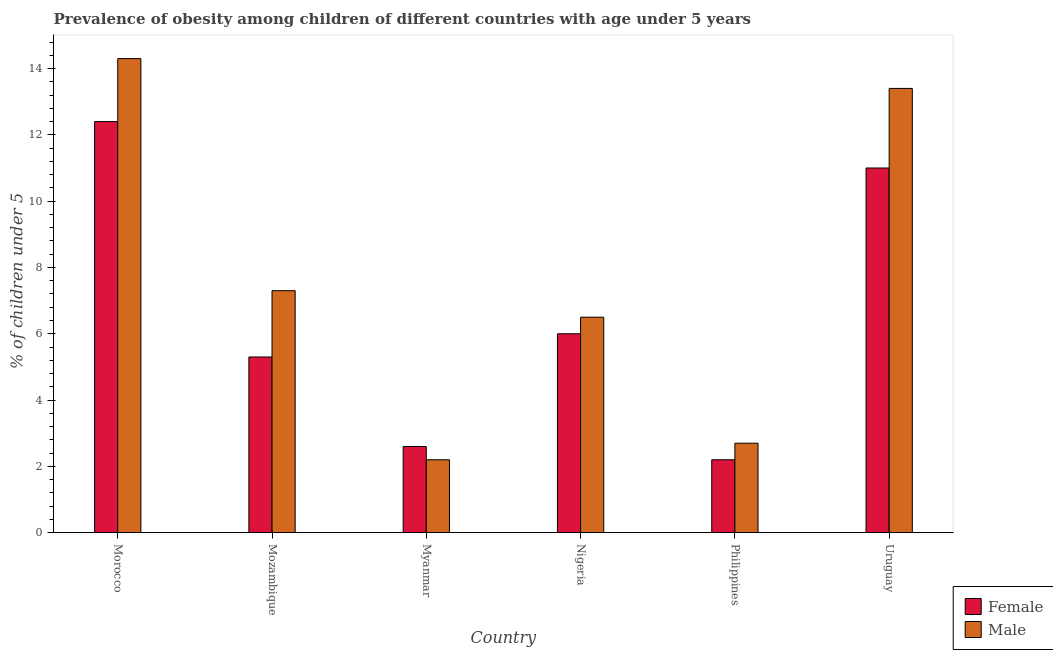Are the number of bars on each tick of the X-axis equal?
Your response must be concise. Yes. How many bars are there on the 2nd tick from the left?
Your answer should be compact. 2. How many bars are there on the 3rd tick from the right?
Offer a very short reply. 2. What is the label of the 2nd group of bars from the left?
Your answer should be compact. Mozambique. In how many cases, is the number of bars for a given country not equal to the number of legend labels?
Make the answer very short. 0. What is the percentage of obese female children in Morocco?
Make the answer very short. 12.4. Across all countries, what is the maximum percentage of obese male children?
Keep it short and to the point. 14.3. Across all countries, what is the minimum percentage of obese female children?
Offer a terse response. 2.2. In which country was the percentage of obese male children maximum?
Offer a very short reply. Morocco. In which country was the percentage of obese male children minimum?
Offer a terse response. Myanmar. What is the total percentage of obese male children in the graph?
Ensure brevity in your answer.  46.4. What is the difference between the percentage of obese female children in Morocco and that in Mozambique?
Offer a very short reply. 7.1. What is the average percentage of obese male children per country?
Your answer should be compact. 7.73. What is the difference between the percentage of obese male children and percentage of obese female children in Nigeria?
Provide a short and direct response. 0.5. What is the ratio of the percentage of obese male children in Mozambique to that in Myanmar?
Offer a very short reply. 3.32. Is the percentage of obese female children in Mozambique less than that in Myanmar?
Keep it short and to the point. No. What is the difference between the highest and the second highest percentage of obese male children?
Offer a terse response. 0.9. What is the difference between the highest and the lowest percentage of obese male children?
Keep it short and to the point. 12.1. Is the sum of the percentage of obese male children in Morocco and Philippines greater than the maximum percentage of obese female children across all countries?
Your response must be concise. Yes. What does the 1st bar from the left in Mozambique represents?
Your answer should be compact. Female. How many bars are there?
Offer a terse response. 12. Does the graph contain any zero values?
Your answer should be compact. No. Does the graph contain grids?
Give a very brief answer. No. Where does the legend appear in the graph?
Provide a succinct answer. Bottom right. How are the legend labels stacked?
Ensure brevity in your answer.  Vertical. What is the title of the graph?
Keep it short and to the point. Prevalence of obesity among children of different countries with age under 5 years. What is the label or title of the Y-axis?
Your response must be concise.  % of children under 5. What is the  % of children under 5 in Female in Morocco?
Offer a terse response. 12.4. What is the  % of children under 5 of Male in Morocco?
Keep it short and to the point. 14.3. What is the  % of children under 5 of Female in Mozambique?
Make the answer very short. 5.3. What is the  % of children under 5 in Male in Mozambique?
Offer a very short reply. 7.3. What is the  % of children under 5 of Female in Myanmar?
Provide a succinct answer. 2.6. What is the  % of children under 5 of Male in Myanmar?
Your response must be concise. 2.2. What is the  % of children under 5 of Female in Philippines?
Ensure brevity in your answer.  2.2. What is the  % of children under 5 of Male in Philippines?
Your answer should be very brief. 2.7. What is the  % of children under 5 in Female in Uruguay?
Provide a short and direct response. 11. What is the  % of children under 5 in Male in Uruguay?
Give a very brief answer. 13.4. Across all countries, what is the maximum  % of children under 5 of Female?
Offer a very short reply. 12.4. Across all countries, what is the maximum  % of children under 5 of Male?
Offer a terse response. 14.3. Across all countries, what is the minimum  % of children under 5 in Female?
Offer a very short reply. 2.2. Across all countries, what is the minimum  % of children under 5 of Male?
Keep it short and to the point. 2.2. What is the total  % of children under 5 in Female in the graph?
Provide a succinct answer. 39.5. What is the total  % of children under 5 of Male in the graph?
Provide a succinct answer. 46.4. What is the difference between the  % of children under 5 in Female in Morocco and that in Mozambique?
Your response must be concise. 7.1. What is the difference between the  % of children under 5 in Female in Morocco and that in Myanmar?
Keep it short and to the point. 9.8. What is the difference between the  % of children under 5 of Female in Morocco and that in Nigeria?
Your answer should be very brief. 6.4. What is the difference between the  % of children under 5 in Female in Morocco and that in Philippines?
Give a very brief answer. 10.2. What is the difference between the  % of children under 5 of Female in Mozambique and that in Myanmar?
Keep it short and to the point. 2.7. What is the difference between the  % of children under 5 in Male in Mozambique and that in Myanmar?
Provide a short and direct response. 5.1. What is the difference between the  % of children under 5 in Female in Mozambique and that in Nigeria?
Ensure brevity in your answer.  -0.7. What is the difference between the  % of children under 5 in Male in Mozambique and that in Nigeria?
Provide a short and direct response. 0.8. What is the difference between the  % of children under 5 in Female in Mozambique and that in Philippines?
Make the answer very short. 3.1. What is the difference between the  % of children under 5 in Male in Mozambique and that in Philippines?
Make the answer very short. 4.6. What is the difference between the  % of children under 5 in Male in Mozambique and that in Uruguay?
Your answer should be very brief. -6.1. What is the difference between the  % of children under 5 in Female in Myanmar and that in Nigeria?
Provide a succinct answer. -3.4. What is the difference between the  % of children under 5 in Male in Myanmar and that in Philippines?
Offer a very short reply. -0.5. What is the difference between the  % of children under 5 of Female in Myanmar and that in Uruguay?
Give a very brief answer. -8.4. What is the difference between the  % of children under 5 of Male in Myanmar and that in Uruguay?
Provide a short and direct response. -11.2. What is the difference between the  % of children under 5 in Female in Philippines and that in Uruguay?
Provide a succinct answer. -8.8. What is the difference between the  % of children under 5 of Male in Philippines and that in Uruguay?
Provide a succinct answer. -10.7. What is the difference between the  % of children under 5 of Female in Morocco and the  % of children under 5 of Male in Mozambique?
Provide a succinct answer. 5.1. What is the difference between the  % of children under 5 in Female in Mozambique and the  % of children under 5 in Male in Nigeria?
Offer a terse response. -1.2. What is the difference between the  % of children under 5 in Female in Myanmar and the  % of children under 5 in Male in Nigeria?
Provide a succinct answer. -3.9. What is the difference between the  % of children under 5 of Female in Myanmar and the  % of children under 5 of Male in Philippines?
Provide a succinct answer. -0.1. What is the difference between the  % of children under 5 of Female in Nigeria and the  % of children under 5 of Male in Philippines?
Provide a short and direct response. 3.3. What is the difference between the  % of children under 5 in Female in Nigeria and the  % of children under 5 in Male in Uruguay?
Offer a very short reply. -7.4. What is the difference between the  % of children under 5 of Female in Philippines and the  % of children under 5 of Male in Uruguay?
Your response must be concise. -11.2. What is the average  % of children under 5 in Female per country?
Provide a succinct answer. 6.58. What is the average  % of children under 5 of Male per country?
Ensure brevity in your answer.  7.73. What is the difference between the  % of children under 5 in Female and  % of children under 5 in Male in Philippines?
Keep it short and to the point. -0.5. What is the difference between the  % of children under 5 of Female and  % of children under 5 of Male in Uruguay?
Keep it short and to the point. -2.4. What is the ratio of the  % of children under 5 in Female in Morocco to that in Mozambique?
Your response must be concise. 2.34. What is the ratio of the  % of children under 5 in Male in Morocco to that in Mozambique?
Provide a short and direct response. 1.96. What is the ratio of the  % of children under 5 in Female in Morocco to that in Myanmar?
Make the answer very short. 4.77. What is the ratio of the  % of children under 5 of Female in Morocco to that in Nigeria?
Keep it short and to the point. 2.07. What is the ratio of the  % of children under 5 of Male in Morocco to that in Nigeria?
Provide a short and direct response. 2.2. What is the ratio of the  % of children under 5 of Female in Morocco to that in Philippines?
Keep it short and to the point. 5.64. What is the ratio of the  % of children under 5 in Male in Morocco to that in Philippines?
Make the answer very short. 5.3. What is the ratio of the  % of children under 5 of Female in Morocco to that in Uruguay?
Offer a terse response. 1.13. What is the ratio of the  % of children under 5 in Male in Morocco to that in Uruguay?
Offer a terse response. 1.07. What is the ratio of the  % of children under 5 in Female in Mozambique to that in Myanmar?
Give a very brief answer. 2.04. What is the ratio of the  % of children under 5 of Male in Mozambique to that in Myanmar?
Ensure brevity in your answer.  3.32. What is the ratio of the  % of children under 5 of Female in Mozambique to that in Nigeria?
Keep it short and to the point. 0.88. What is the ratio of the  % of children under 5 of Male in Mozambique to that in Nigeria?
Provide a succinct answer. 1.12. What is the ratio of the  % of children under 5 in Female in Mozambique to that in Philippines?
Your response must be concise. 2.41. What is the ratio of the  % of children under 5 of Male in Mozambique to that in Philippines?
Provide a short and direct response. 2.7. What is the ratio of the  % of children under 5 in Female in Mozambique to that in Uruguay?
Your response must be concise. 0.48. What is the ratio of the  % of children under 5 in Male in Mozambique to that in Uruguay?
Your answer should be very brief. 0.54. What is the ratio of the  % of children under 5 in Female in Myanmar to that in Nigeria?
Provide a succinct answer. 0.43. What is the ratio of the  % of children under 5 in Male in Myanmar to that in Nigeria?
Your answer should be very brief. 0.34. What is the ratio of the  % of children under 5 of Female in Myanmar to that in Philippines?
Your response must be concise. 1.18. What is the ratio of the  % of children under 5 in Male in Myanmar to that in Philippines?
Provide a succinct answer. 0.81. What is the ratio of the  % of children under 5 of Female in Myanmar to that in Uruguay?
Offer a terse response. 0.24. What is the ratio of the  % of children under 5 of Male in Myanmar to that in Uruguay?
Make the answer very short. 0.16. What is the ratio of the  % of children under 5 of Female in Nigeria to that in Philippines?
Make the answer very short. 2.73. What is the ratio of the  % of children under 5 of Male in Nigeria to that in Philippines?
Keep it short and to the point. 2.41. What is the ratio of the  % of children under 5 of Female in Nigeria to that in Uruguay?
Give a very brief answer. 0.55. What is the ratio of the  % of children under 5 in Male in Nigeria to that in Uruguay?
Your answer should be very brief. 0.49. What is the ratio of the  % of children under 5 of Female in Philippines to that in Uruguay?
Give a very brief answer. 0.2. What is the ratio of the  % of children under 5 in Male in Philippines to that in Uruguay?
Your response must be concise. 0.2. What is the difference between the highest and the second highest  % of children under 5 in Male?
Your answer should be very brief. 0.9. What is the difference between the highest and the lowest  % of children under 5 of Female?
Your answer should be compact. 10.2. 